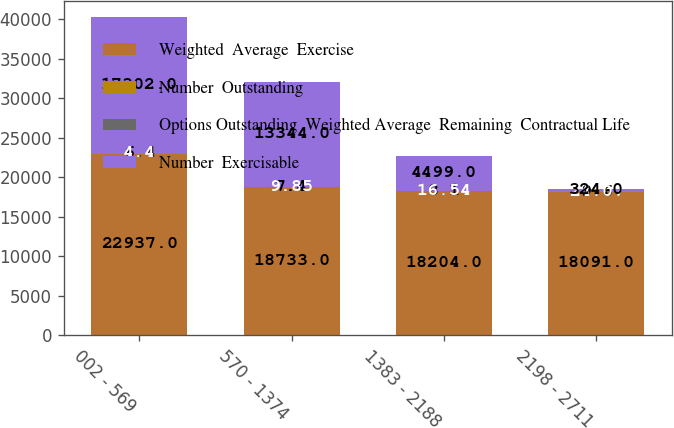<chart> <loc_0><loc_0><loc_500><loc_500><stacked_bar_chart><ecel><fcel>002 - 569<fcel>570 - 1374<fcel>1383 - 2188<fcel>2198 - 2711<nl><fcel>Weighted  Average  Exercise<fcel>22937<fcel>18733<fcel>18204<fcel>18091<nl><fcel>Number  Outstanding<fcel>6.4<fcel>7.4<fcel>8.1<fcel>9.6<nl><fcel>Options Outstanding  Weighted Average  Remaining  Contractual Life<fcel>4.4<fcel>9.85<fcel>16.54<fcel>24.07<nl><fcel>Number  Exercisable<fcel>17302<fcel>13344<fcel>4499<fcel>324<nl></chart> 